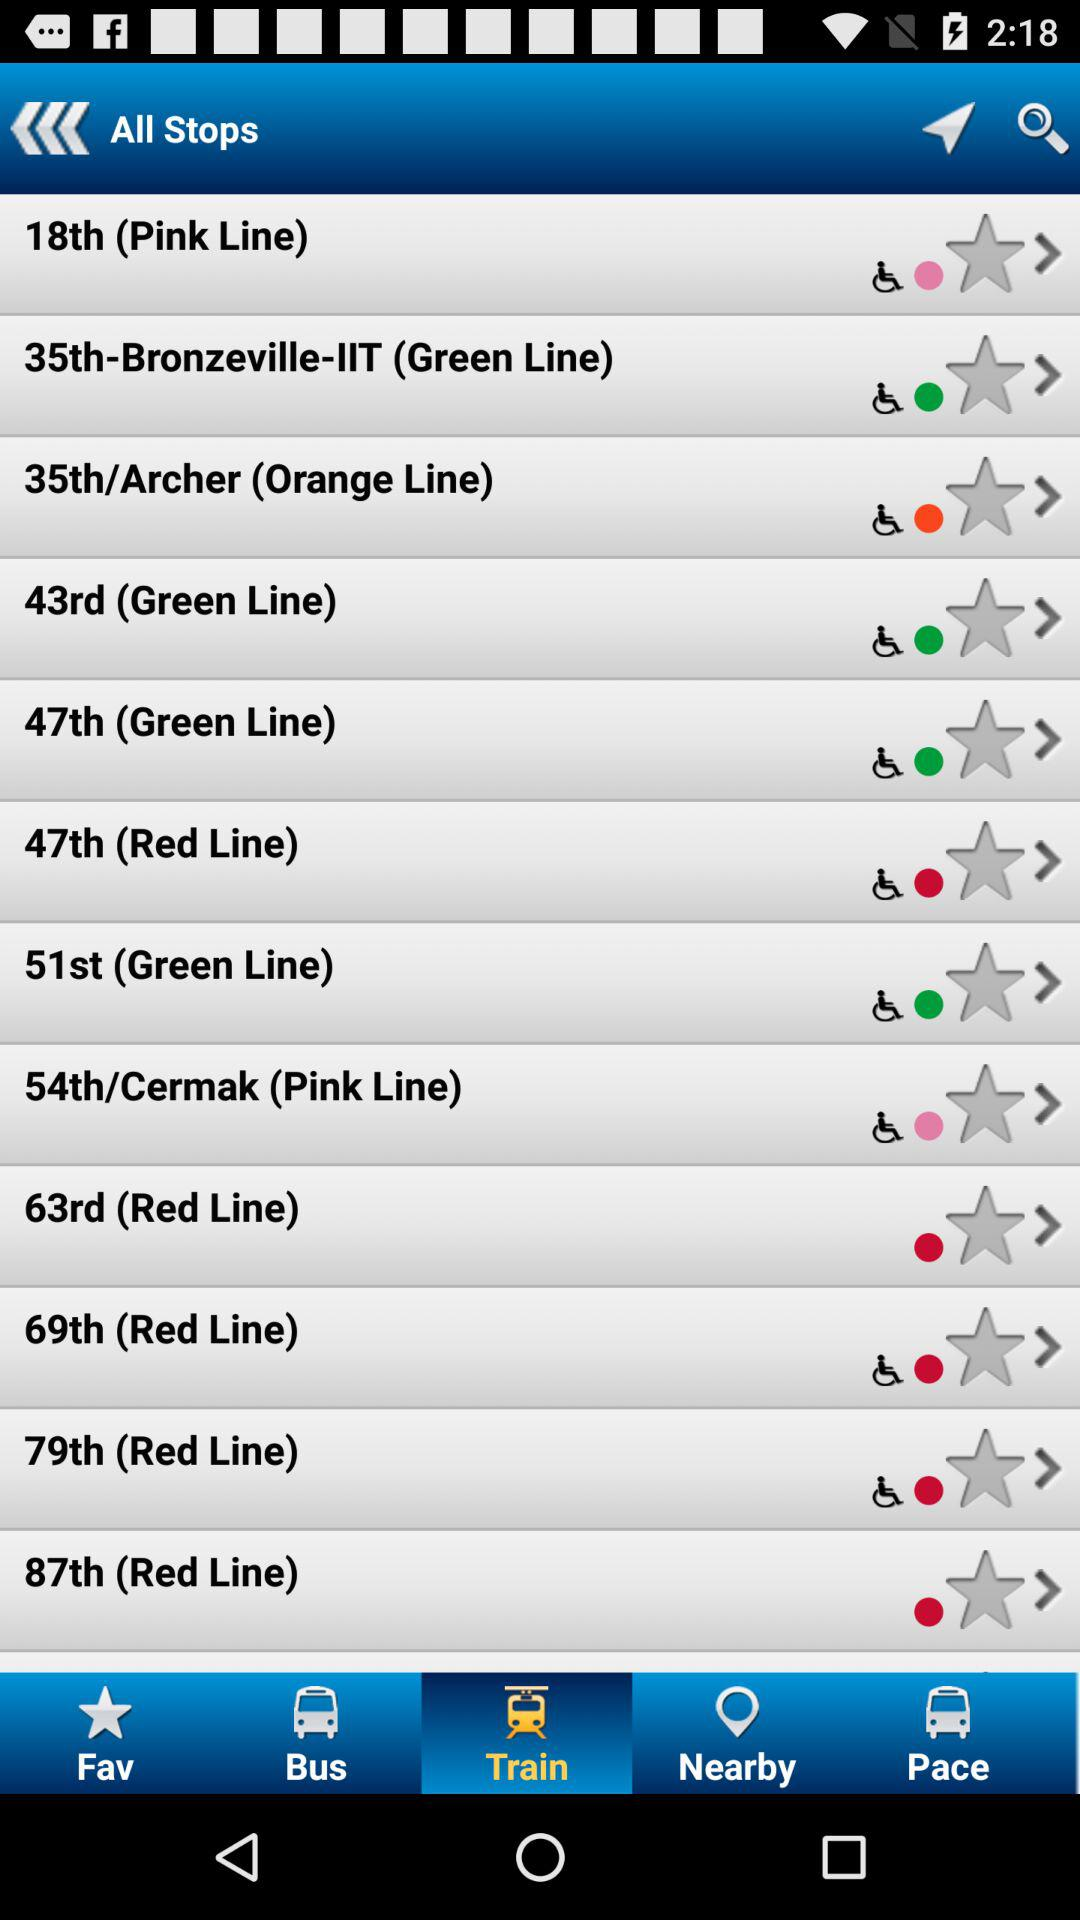What is the line color of the "63rd" stop? The line color of the "63rd" stop is red. 